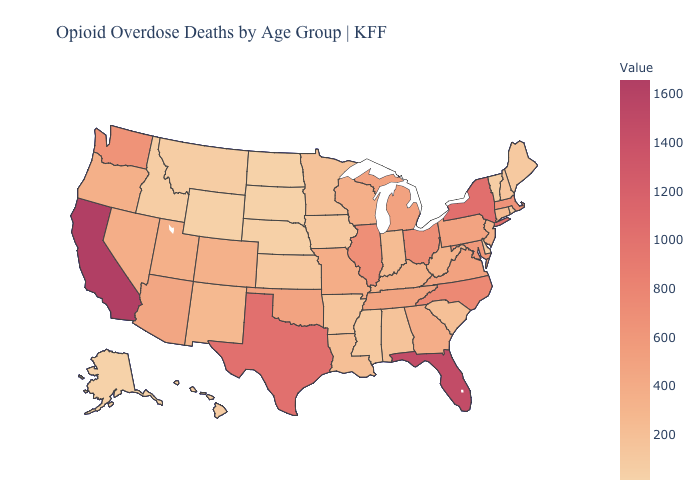Is the legend a continuous bar?
Concise answer only. Yes. Does Alaska have the lowest value in the USA?
Give a very brief answer. Yes. Does Wyoming have a higher value than Wisconsin?
Write a very short answer. No. Which states have the lowest value in the USA?
Keep it brief. Alaska. Which states have the lowest value in the MidWest?
Keep it brief. North Dakota. Does California have the highest value in the USA?
Be succinct. Yes. Which states have the lowest value in the USA?
Answer briefly. Alaska. 